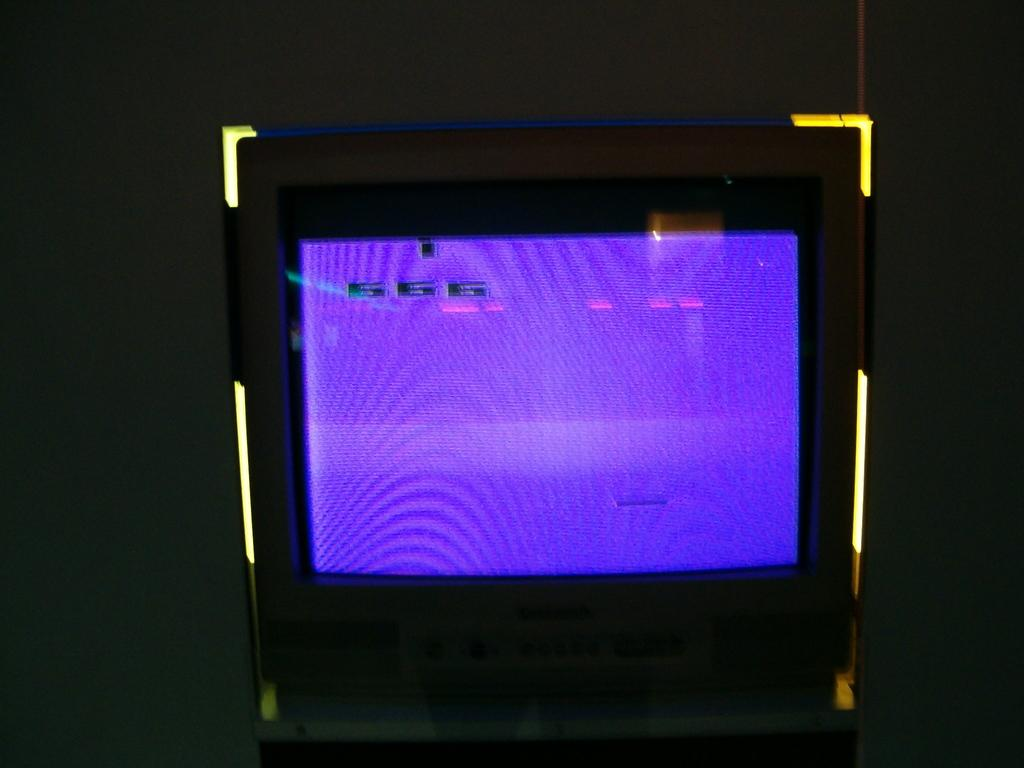<image>
Share a concise interpretation of the image provided. A picture of an old school tank style Panasonic TV. 